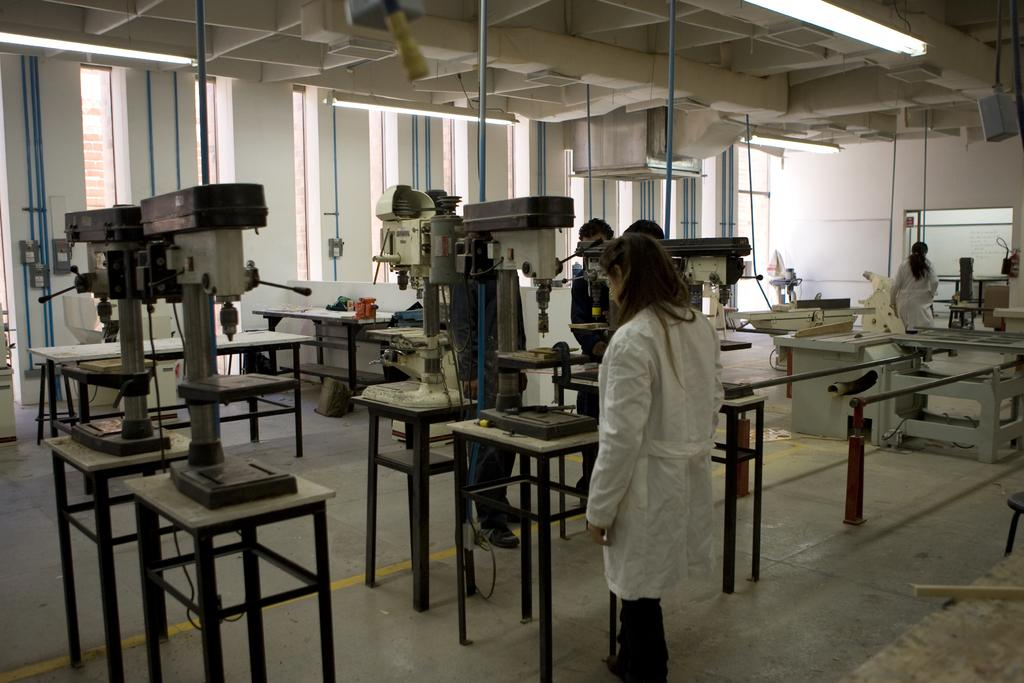What is the person in the image doing? The person is standing on the floor in the image. What else can be seen in the image besides the person? There are many machines placed in the image. What is the background of the image made up of? There is a wall in the image, and possibly other elements that are not specified. What is the board used for in the image? The purpose of the board in the image is not clear from the given facts. What type of house can be seen in the harbor in the image? There is no house or harbor present in the image; it features a person standing on the floor and many machines. 